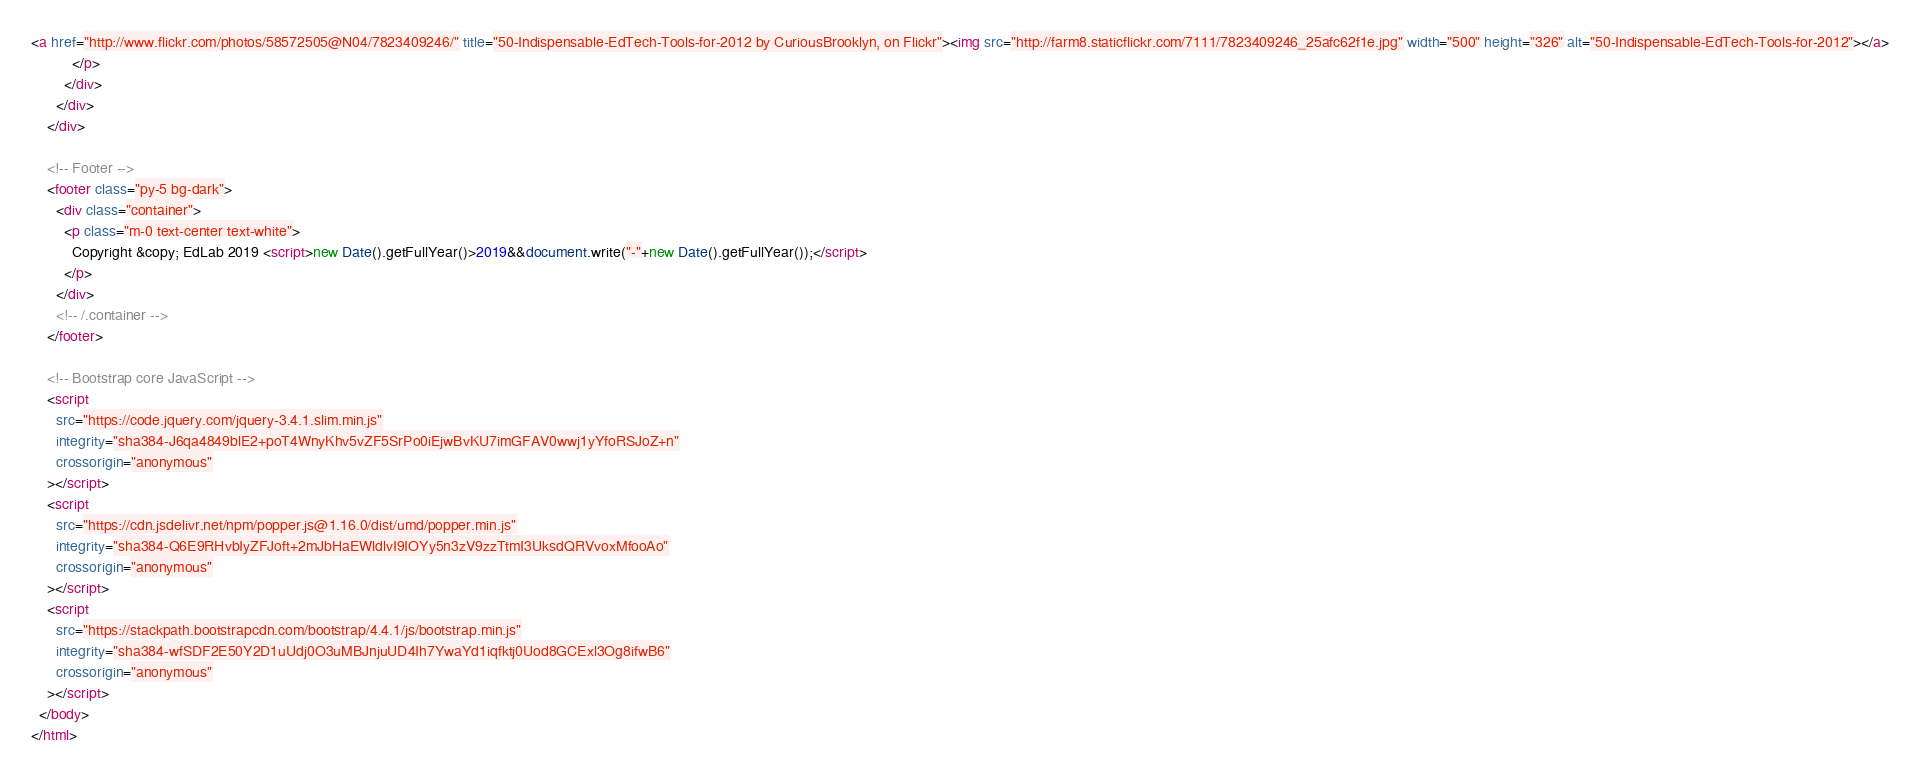Convert code to text. <code><loc_0><loc_0><loc_500><loc_500><_HTML_>
<a href="http://www.flickr.com/photos/58572505@N04/7823409246/" title="50-Indispensable-EdTech-Tools-for-2012 by CuriousBrooklyn, on Flickr"><img src="http://farm8.staticflickr.com/7111/7823409246_25afc62f1e.jpg" width="500" height="326" alt="50-Indispensable-EdTech-Tools-for-2012"></a>
          </p>
        </div>
      </div>
    </div>

    <!-- Footer -->
    <footer class="py-5 bg-dark">
      <div class="container">
        <p class="m-0 text-center text-white">
          Copyright &copy; EdLab 2019 <script>new Date().getFullYear()>2019&&document.write("-"+new Date().getFullYear());</script>
        </p>
      </div>
      <!-- /.container -->
    </footer>

    <!-- Bootstrap core JavaScript -->
    <script
      src="https://code.jquery.com/jquery-3.4.1.slim.min.js"
      integrity="sha384-J6qa4849blE2+poT4WnyKhv5vZF5SrPo0iEjwBvKU7imGFAV0wwj1yYfoRSJoZ+n"
      crossorigin="anonymous"
    ></script>
    <script
      src="https://cdn.jsdelivr.net/npm/popper.js@1.16.0/dist/umd/popper.min.js"
      integrity="sha384-Q6E9RHvbIyZFJoft+2mJbHaEWldlvI9IOYy5n3zV9zzTtmI3UksdQRVvoxMfooAo"
      crossorigin="anonymous"
    ></script>
    <script
      src="https://stackpath.bootstrapcdn.com/bootstrap/4.4.1/js/bootstrap.min.js"
      integrity="sha384-wfSDF2E50Y2D1uUdj0O3uMBJnjuUD4Ih7YwaYd1iqfktj0Uod8GCExl3Og8ifwB6"
      crossorigin="anonymous"
    ></script>
  </body>
</html>
</code> 